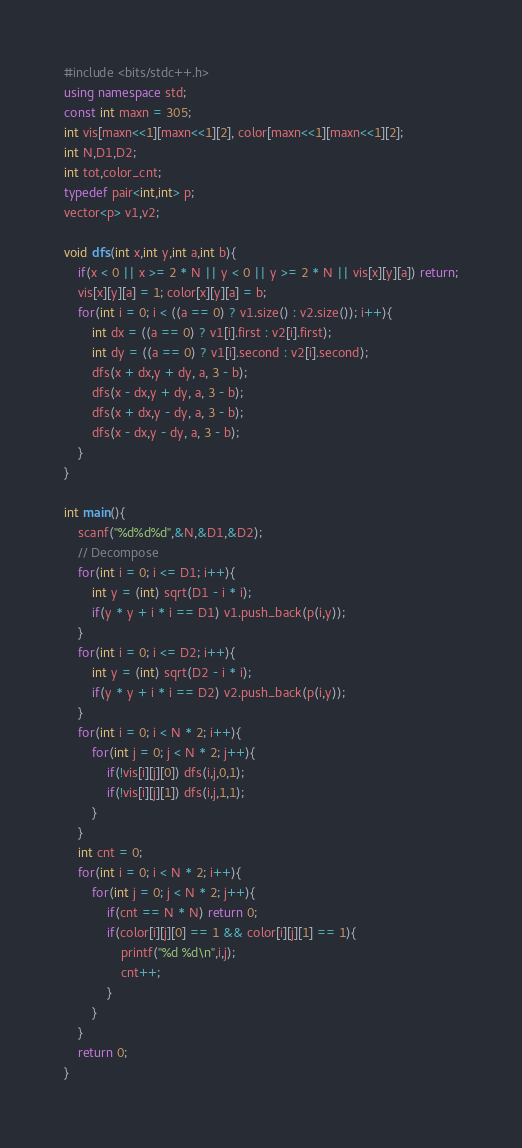Convert code to text. <code><loc_0><loc_0><loc_500><loc_500><_C++_>#include <bits/stdc++.h>
using namespace std;
const int maxn = 305;
int vis[maxn<<1][maxn<<1][2], color[maxn<<1][maxn<<1][2];
int N,D1,D2;
int tot,color_cnt;
typedef pair<int,int> p;
vector<p> v1,v2;

void dfs(int x,int y,int a,int b){
	if(x < 0 || x >= 2 * N || y < 0 || y >= 2 * N || vis[x][y][a]) return;
	vis[x][y][a] = 1; color[x][y][a] = b;
	for(int i = 0; i < ((a == 0) ? v1.size() : v2.size()); i++){
		int dx = ((a == 0) ? v1[i].first : v2[i].first);
		int dy = ((a == 0) ? v1[i].second : v2[i].second);
		dfs(x + dx,y + dy, a, 3 - b);
		dfs(x - dx,y + dy, a, 3 - b);
		dfs(x + dx,y - dy, a, 3 - b);
		dfs(x - dx,y - dy, a, 3 - b);
	} 
}

int main(){
	scanf("%d%d%d",&N,&D1,&D2);
	// Decompose
	for(int i = 0; i <= D1; i++){
		int y = (int) sqrt(D1 - i * i);
		if(y * y + i * i == D1) v1.push_back(p(i,y));
	}
	for(int i = 0; i <= D2; i++){
		int y = (int) sqrt(D2 - i * i);
		if(y * y + i * i == D2) v2.push_back(p(i,y));
	}
	for(int i = 0; i < N * 2; i++){
		for(int j = 0; j < N * 2; j++){
			if(!vis[i][j][0]) dfs(i,j,0,1);
			if(!vis[i][j][1]) dfs(i,j,1,1);
		}
	}
	int cnt = 0;
	for(int i = 0; i < N * 2; i++){
		for(int j = 0; j < N * 2; j++){
			if(cnt == N * N) return 0;
			if(color[i][j][0] == 1 && color[i][j][1] == 1){
				printf("%d %d\n",i,j);
				cnt++; 
			}
		}
	}
	return 0;
}
</code> 